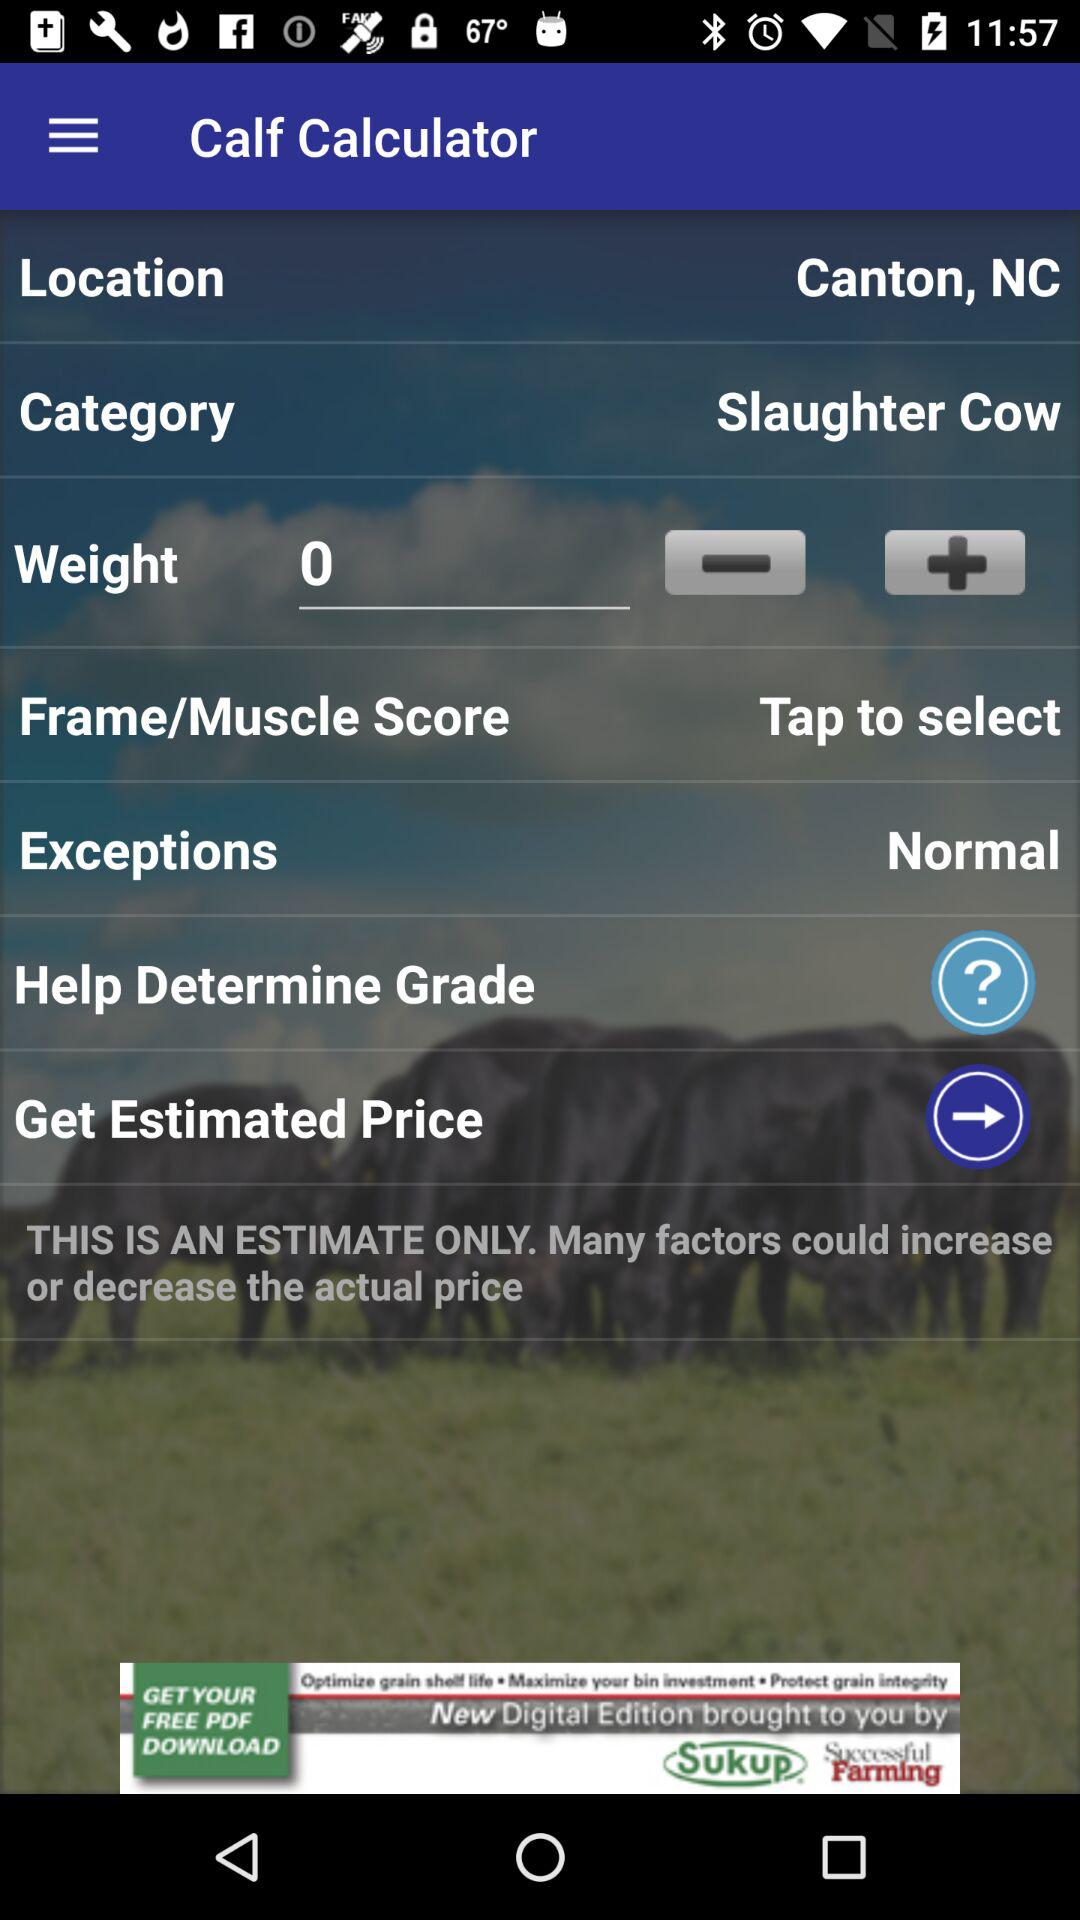Which grade is the cow?
When the provided information is insufficient, respond with <no answer>. <no answer> 